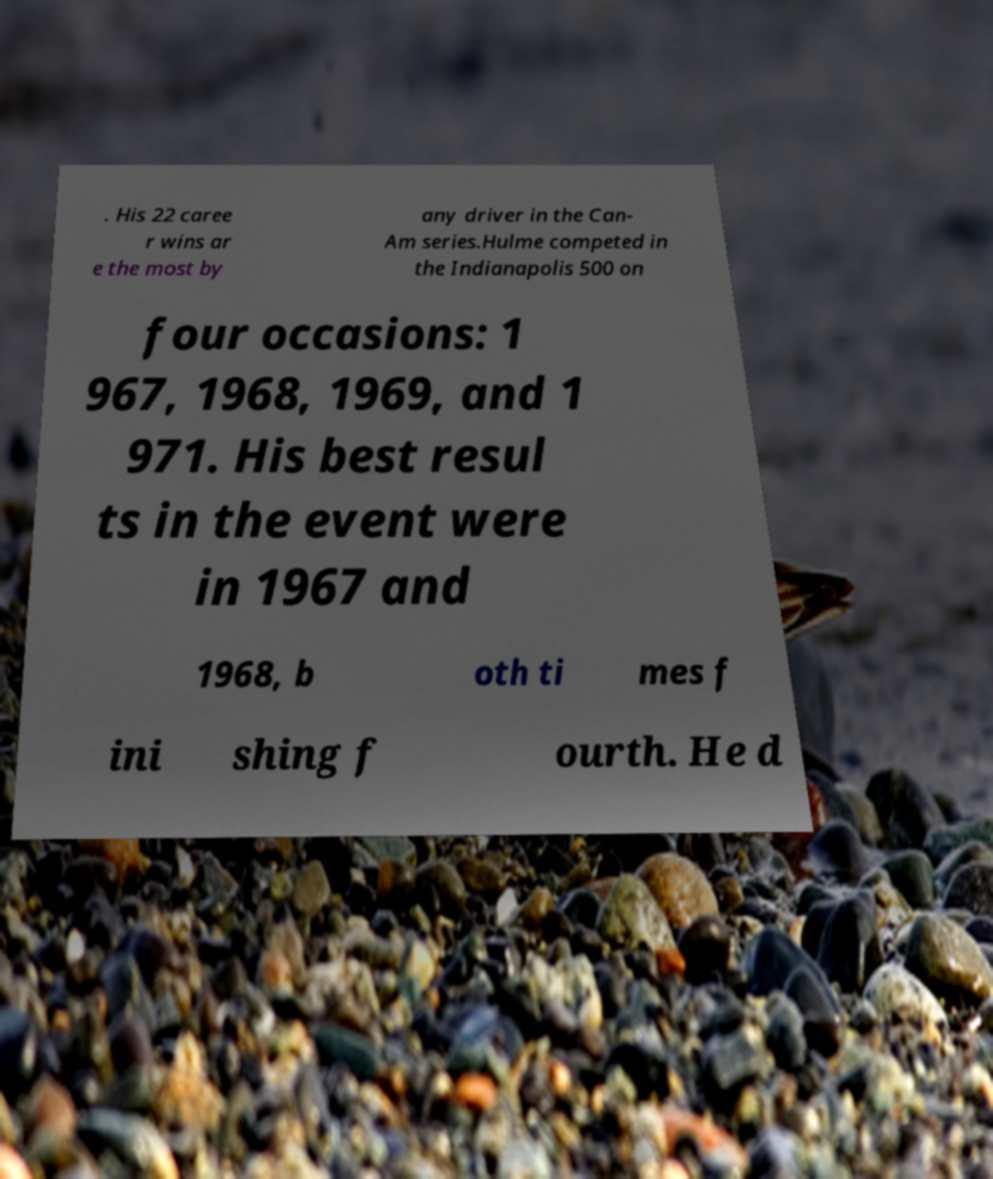Could you extract and type out the text from this image? . His 22 caree r wins ar e the most by any driver in the Can- Am series.Hulme competed in the Indianapolis 500 on four occasions: 1 967, 1968, 1969, and 1 971. His best resul ts in the event were in 1967 and 1968, b oth ti mes f ini shing f ourth. He d 